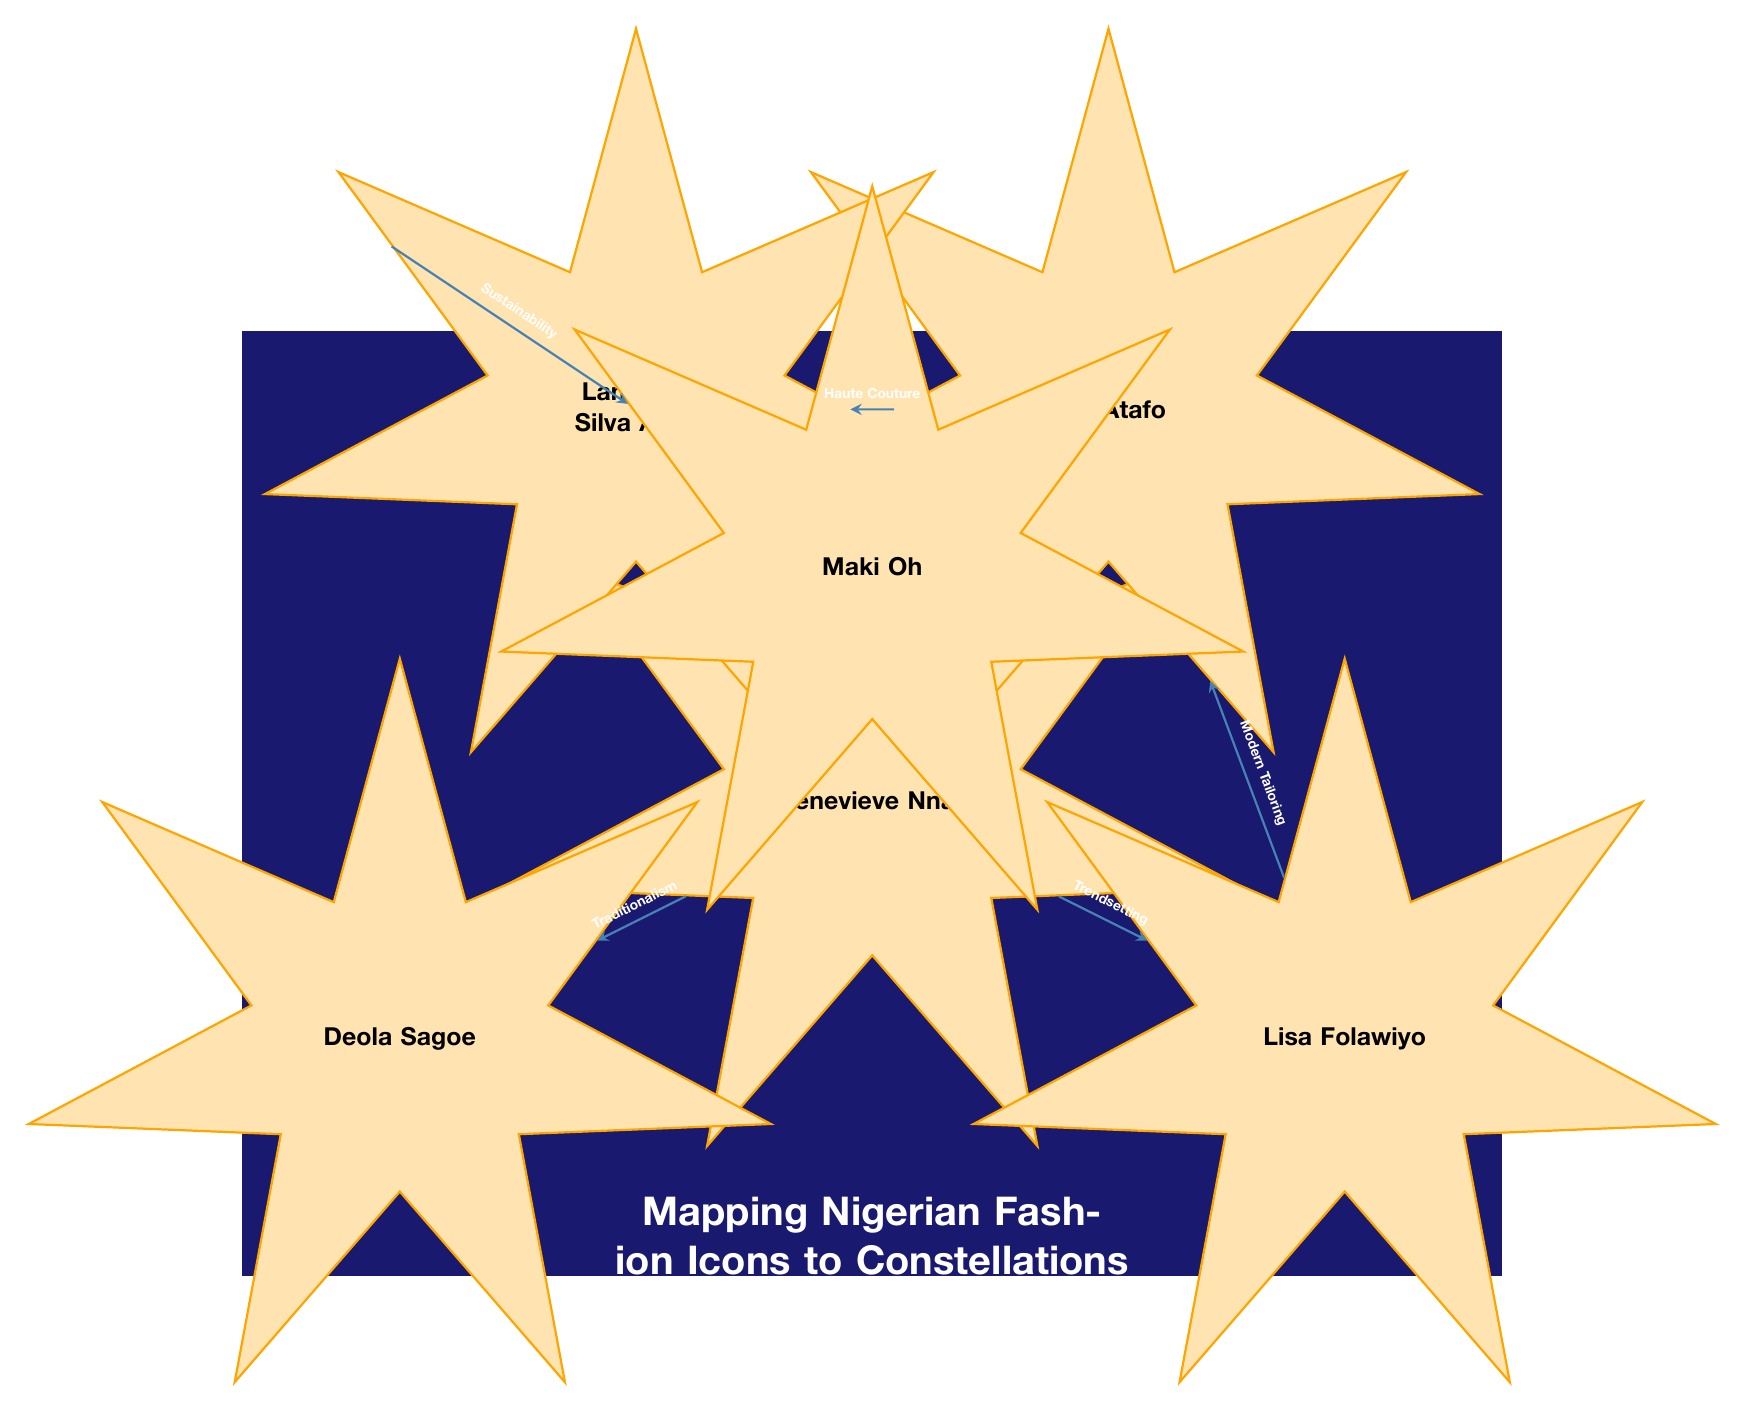What is the total number of fashion icons represented in the diagram? The diagram contains six distinct nodes, each representing a fashion icon. By counting the nodes labeled with the names, we find 6: Genevieve Nnaji, Deola Sagoe, Lisa Folawiyo, Mai Atafo, Lanre Da Silva Ajayi, and Maki Oh.
Answer: 6 What relationship connects Genevieve Nnaji and Deola Sagoe? The arrow connecting Genevieve Nnaji to Deola Sagoe is labeled "Traditionalism," indicating the type of relationship between these two icons.
Answer: Traditionalism Which fashion icon is connected to both Mai Atafo and Lanre Da Silva Ajayi? Upon reviewing the diagram, Maki Oh connects to Lanre Da Silva Ajayi, and there is also a relationship between Mai Atafo and Lanre Da Silva Ajayi showing that Maki Oh is the common connection between them.
Answer: Maki Oh How many edges are there in total in the diagram? Each relationship in the diagram is represented by an edge. Counting these connections, we find that there are a total of 5 edges shown between the icons.
Answer: 5 Which fashion icon focuses on the theme of sustainability? The arrow from Lanre Da Silva Ajayi is specifically labeled with "Sustainability," indicating that this fashion icon is associated with that theme in the context of the diagram.
Answer: Lanre Da Silva Ajayi What relationship does Lisa Folawiyo share with Mai Atafo? Upon examining the diagram, the edge connecting Lisa Folawiyo to Mai Atafo is labeled "Modern Tailoring," thus defining their relationship.
Answer: Modern Tailoring Which two fashion icons are connected through the theme of Haute Couture? The edge connecting Mai Atafo to Lanre Da Silva Ajayi is labeled "Haute Couture," indicating this specific theme, thus the connection exists between these two icons.
Answer: Mai Atafo and Lanre Da Silva Ajayi What is the background color of the diagram? The background of the diagram fills a rectangle colored in a deep shade, designated as dark blue in the diagram's definitions, which provides a contrasting backdrop to the icons.
Answer: Deep blue 